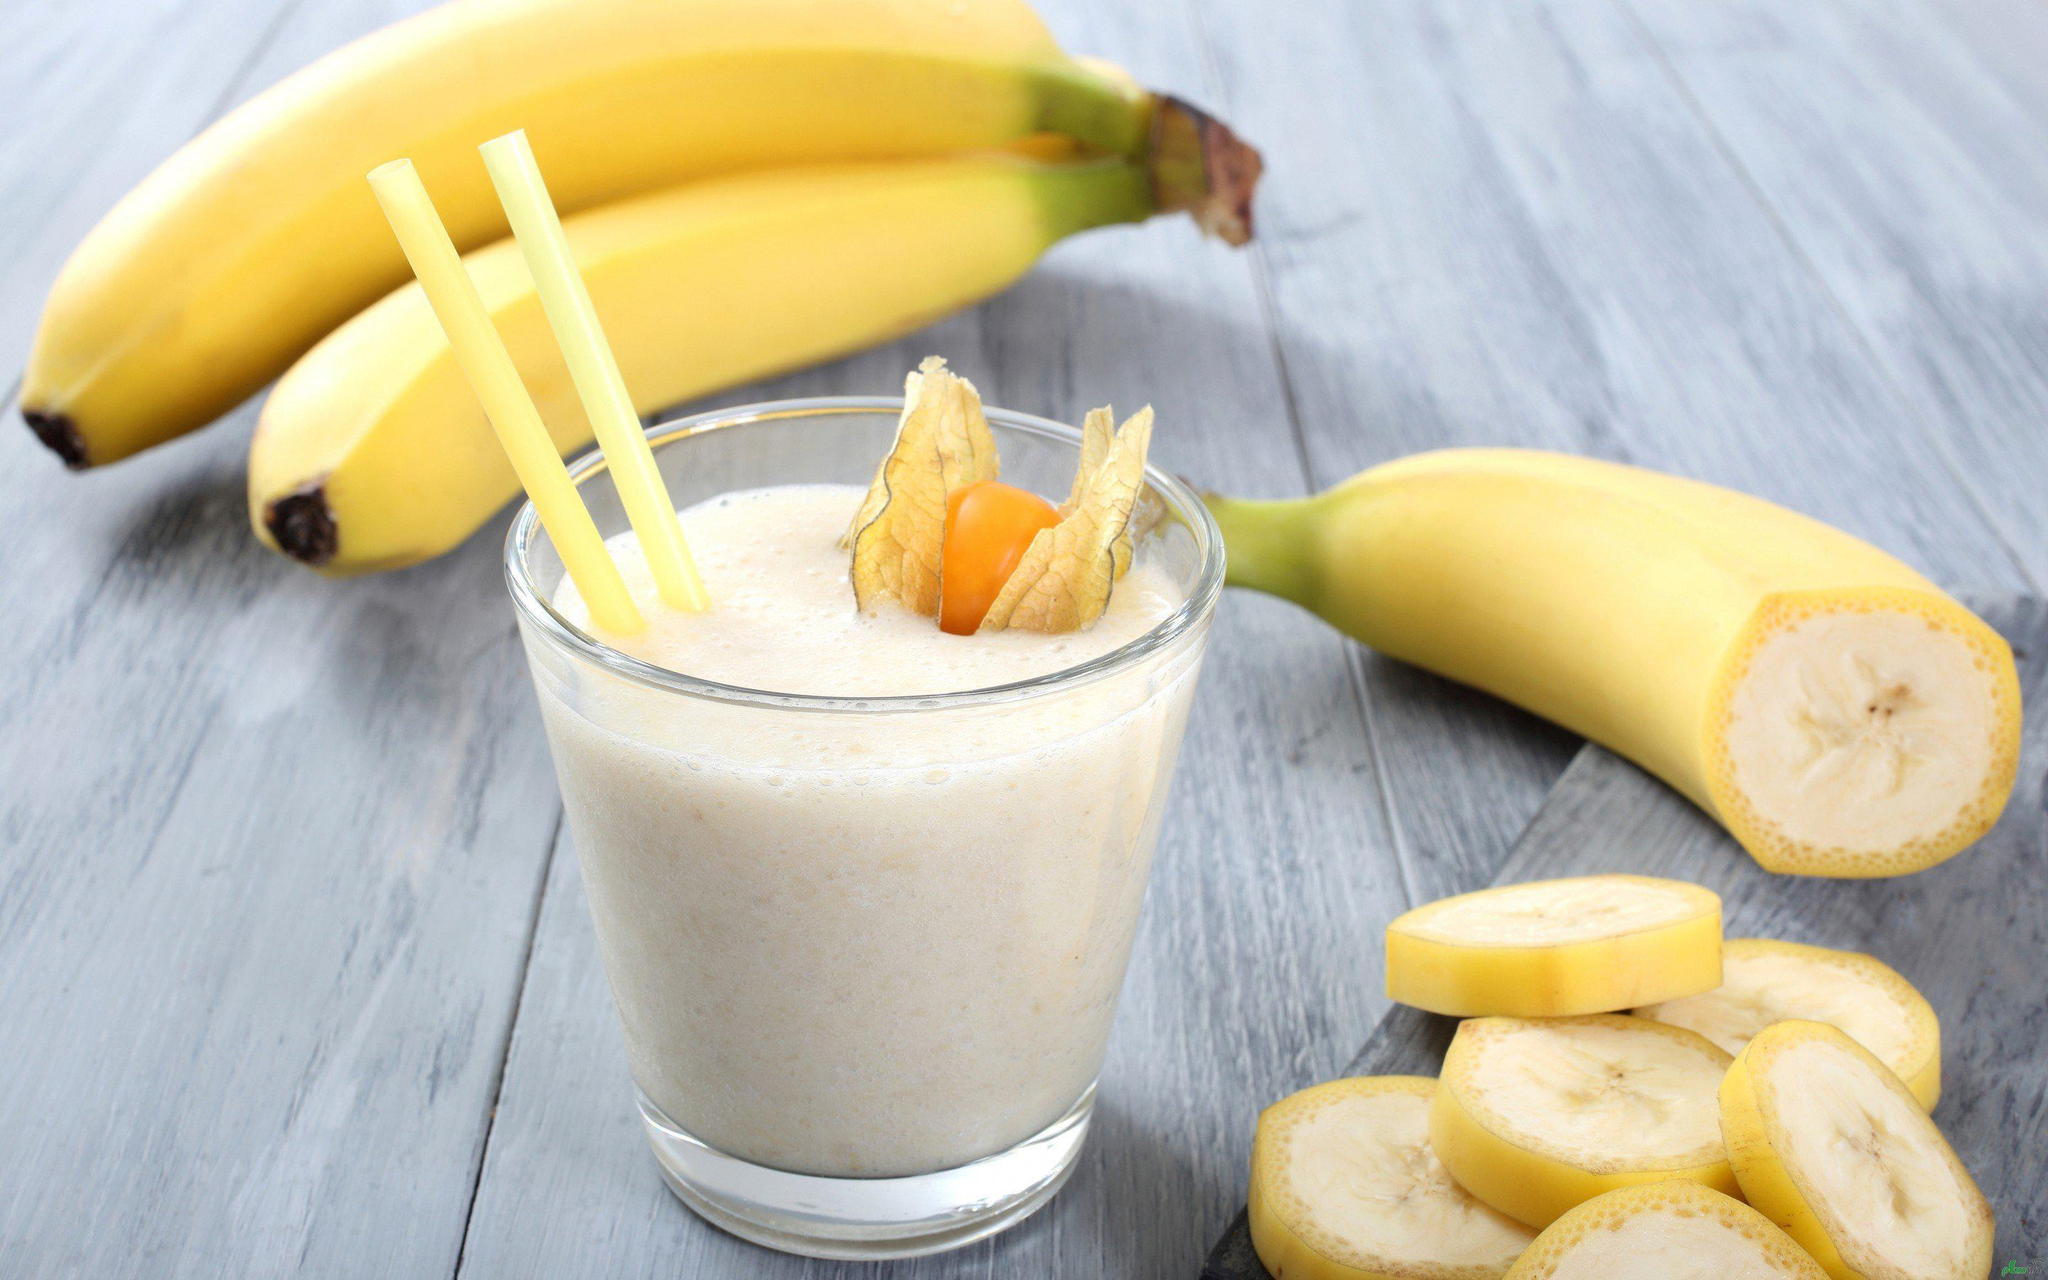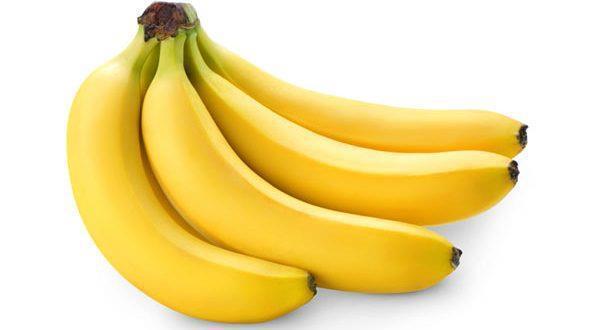The first image is the image on the left, the second image is the image on the right. Assess this claim about the two images: "A glass sits near a few bananas in one of the images.". Correct or not? Answer yes or no. Yes. The first image is the image on the left, the second image is the image on the right. For the images shown, is this caption "One image shows a beverage in a clear glass in front of joined bananas, and the other image contains only yellow bananas in a bunch." true? Answer yes or no. Yes. 